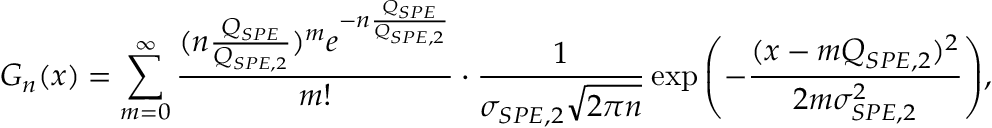<formula> <loc_0><loc_0><loc_500><loc_500>G _ { n } ( x ) = \sum _ { m = 0 } ^ { \infty } \frac { ( n \frac { Q _ { S P E } } { Q _ { S P E , 2 } } ) ^ { m } e ^ { - n \frac { Q _ { S P E } } { Q _ { S P E , 2 } } } } { m ! } \cdot \frac { 1 } { \sigma _ { S P E , 2 } \sqrt { 2 \pi n } } \exp { \left ( - \frac { ( x - m Q _ { S P E , 2 } ) ^ { 2 } } { 2 m \sigma _ { S P E , 2 } ^ { 2 } } \right ) } ,</formula> 